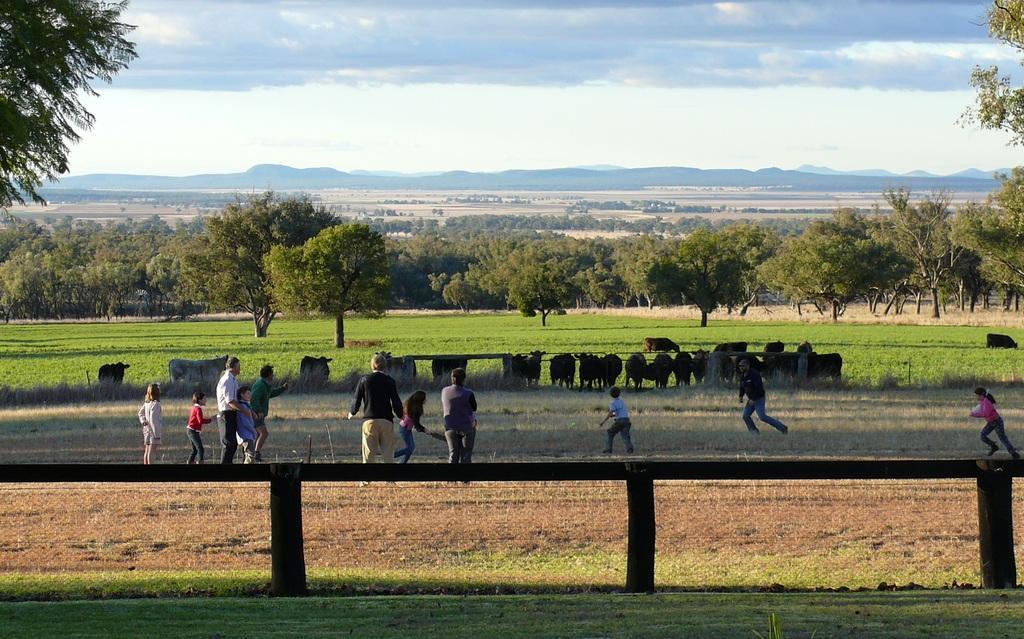Can you describe this image briefly? In this image I can see few trees, mountains, few animals, few people are standing and few people are running. The sky is in white color. 